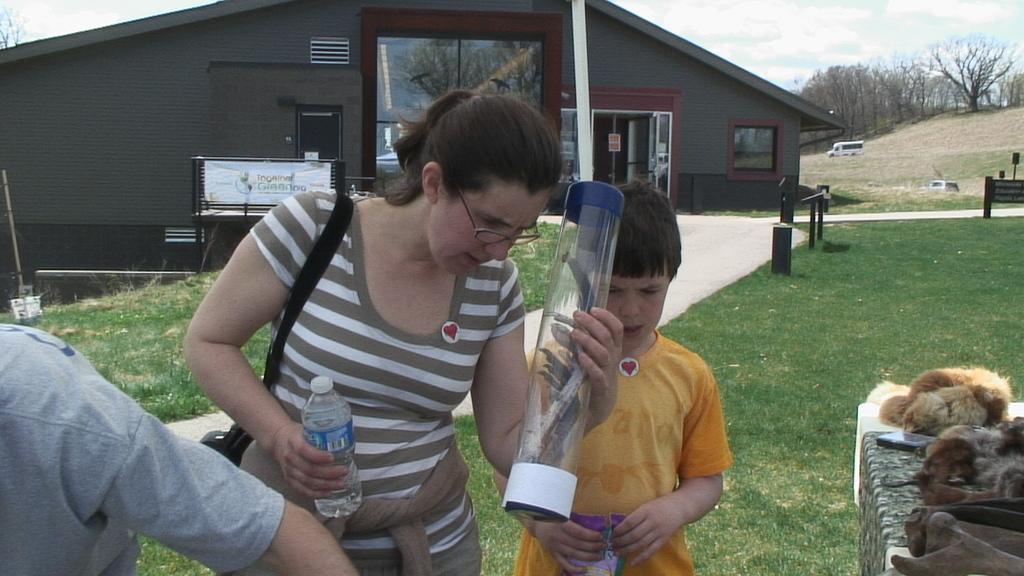In one or two sentences, can you explain what this image depicts? In the foreground of the picture there are people, desk, on the desk there are some objects. In the center the woman is holding a bottle and other objects. In the center there are boards, grass, building and road. In the background towards right there are trees, vehicles, grass. At the top left there is a tree. At the top it is sky. 